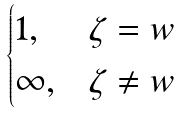<formula> <loc_0><loc_0><loc_500><loc_500>\begin{cases} 1 , & \zeta = w \\ \infty , & \zeta \not = w \end{cases}</formula> 